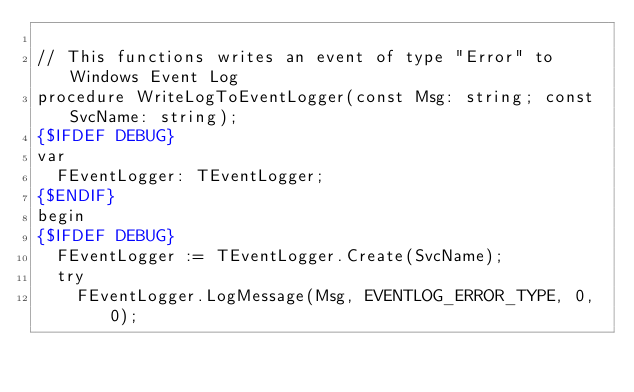Convert code to text. <code><loc_0><loc_0><loc_500><loc_500><_Pascal_>
// This functions writes an event of type "Error" to Windows Event Log
procedure WriteLogToEventLogger(const Msg: string; const SvcName: string);
{$IFDEF DEBUG}
var
  FEventLogger: TEventLogger;
{$ENDIF}
begin
{$IFDEF DEBUG}
  FEventLogger := TEventLogger.Create(SvcName);
  try
    FEventLogger.LogMessage(Msg, EVENTLOG_ERROR_TYPE, 0, 0);</code> 